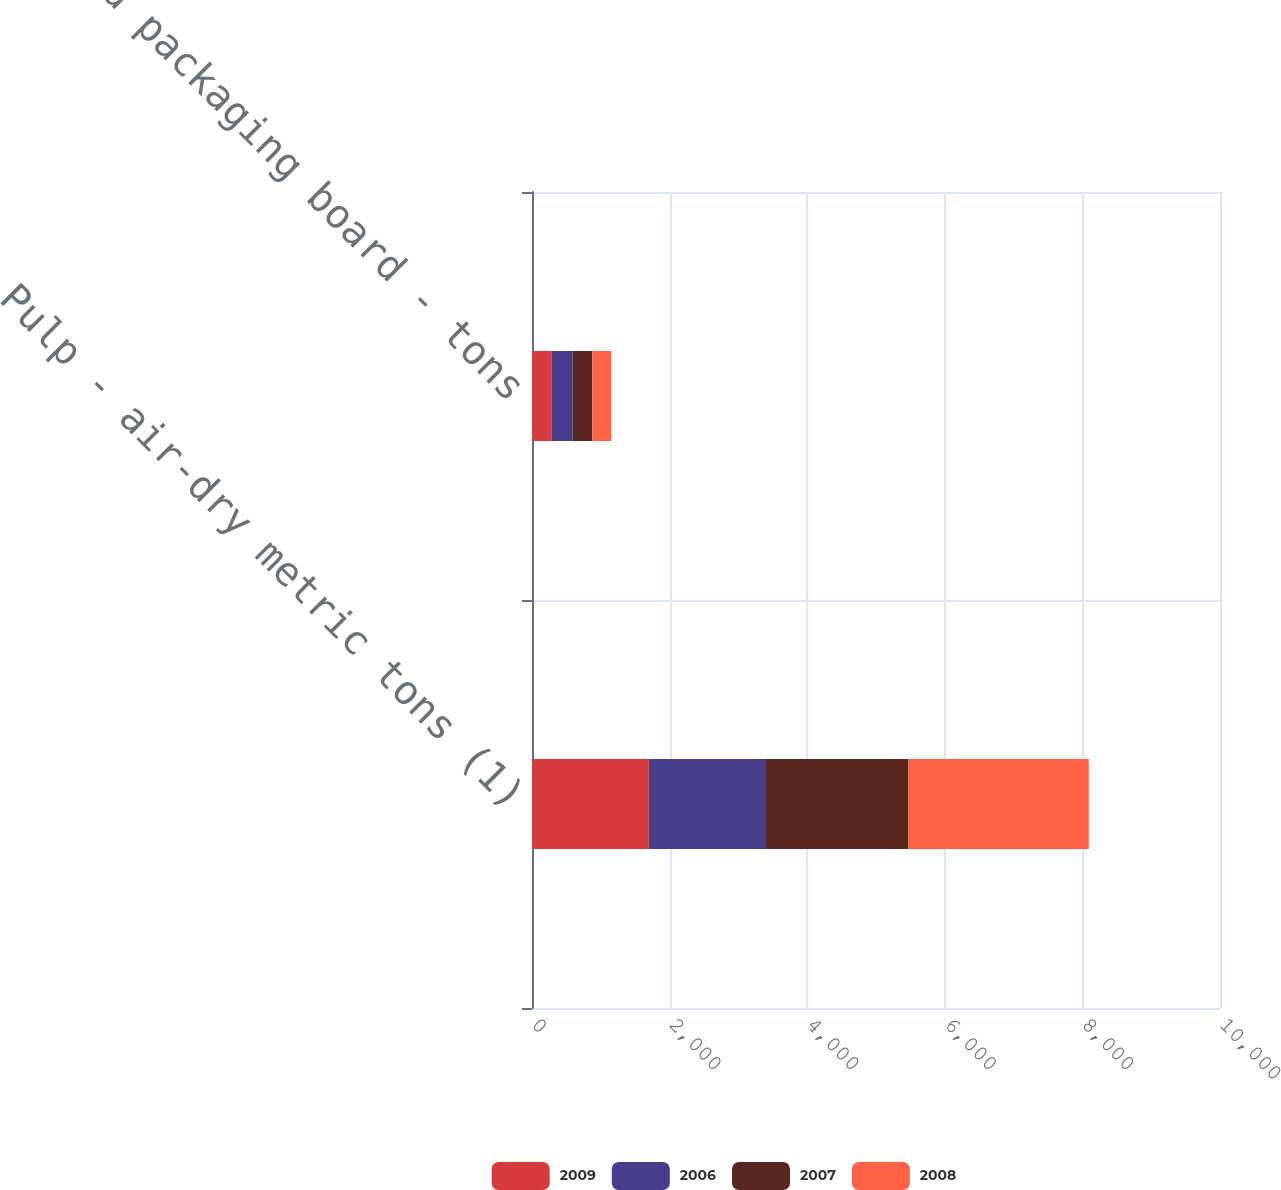Convert chart to OTSL. <chart><loc_0><loc_0><loc_500><loc_500><stacked_bar_chart><ecel><fcel>Pulp - air-dry metric tons (1)<fcel>Liquid packaging board - tons<nl><fcel>2009<fcel>1697<fcel>288<nl><fcel>2006<fcel>1704<fcel>302<nl><fcel>2007<fcel>2070<fcel>286<nl><fcel>2008<fcel>2621<fcel>275<nl></chart> 